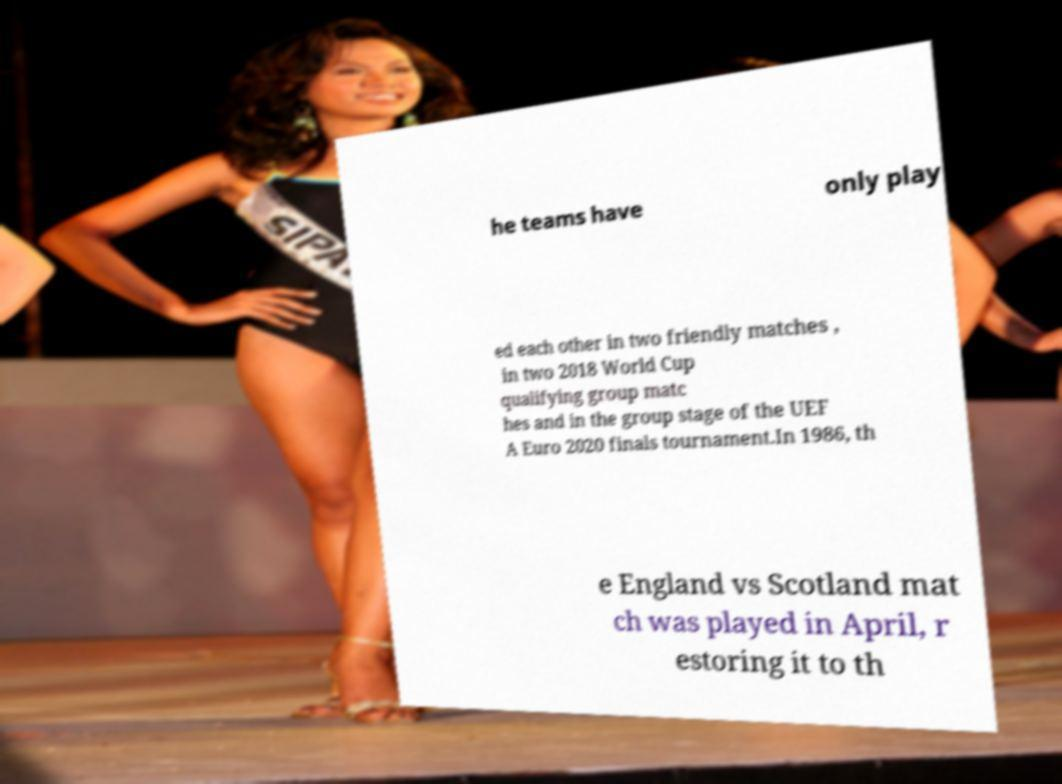Can you read and provide the text displayed in the image?This photo seems to have some interesting text. Can you extract and type it out for me? he teams have only play ed each other in two friendly matches , in two 2018 World Cup qualifying group matc hes and in the group stage of the UEF A Euro 2020 finals tournament.In 1986, th e England vs Scotland mat ch was played in April, r estoring it to th 